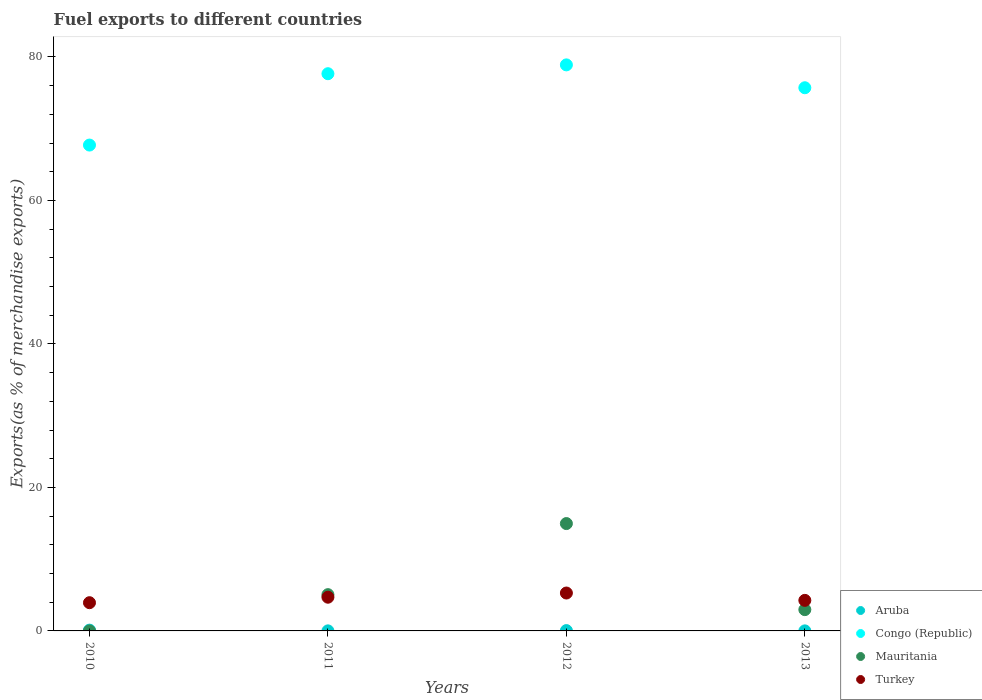How many different coloured dotlines are there?
Your answer should be very brief. 4. Is the number of dotlines equal to the number of legend labels?
Ensure brevity in your answer.  Yes. What is the percentage of exports to different countries in Turkey in 2010?
Give a very brief answer. 3.93. Across all years, what is the maximum percentage of exports to different countries in Congo (Republic)?
Offer a very short reply. 78.9. Across all years, what is the minimum percentage of exports to different countries in Congo (Republic)?
Keep it short and to the point. 67.72. In which year was the percentage of exports to different countries in Turkey maximum?
Your response must be concise. 2012. What is the total percentage of exports to different countries in Congo (Republic) in the graph?
Offer a terse response. 299.99. What is the difference between the percentage of exports to different countries in Turkey in 2010 and that in 2012?
Your answer should be very brief. -1.35. What is the difference between the percentage of exports to different countries in Mauritania in 2011 and the percentage of exports to different countries in Congo (Republic) in 2013?
Provide a succinct answer. -70.65. What is the average percentage of exports to different countries in Congo (Republic) per year?
Your answer should be very brief. 75. In the year 2012, what is the difference between the percentage of exports to different countries in Mauritania and percentage of exports to different countries in Congo (Republic)?
Your answer should be very brief. -63.93. In how many years, is the percentage of exports to different countries in Congo (Republic) greater than 24 %?
Provide a succinct answer. 4. What is the ratio of the percentage of exports to different countries in Congo (Republic) in 2011 to that in 2013?
Provide a short and direct response. 1.03. What is the difference between the highest and the second highest percentage of exports to different countries in Aruba?
Offer a very short reply. 0.06. What is the difference between the highest and the lowest percentage of exports to different countries in Mauritania?
Make the answer very short. 14.96. In how many years, is the percentage of exports to different countries in Aruba greater than the average percentage of exports to different countries in Aruba taken over all years?
Your answer should be compact. 2. Is it the case that in every year, the sum of the percentage of exports to different countries in Mauritania and percentage of exports to different countries in Aruba  is greater than the sum of percentage of exports to different countries in Congo (Republic) and percentage of exports to different countries in Turkey?
Keep it short and to the point. No. Is it the case that in every year, the sum of the percentage of exports to different countries in Turkey and percentage of exports to different countries in Congo (Republic)  is greater than the percentage of exports to different countries in Aruba?
Keep it short and to the point. Yes. Does the percentage of exports to different countries in Mauritania monotonically increase over the years?
Offer a terse response. No. Is the percentage of exports to different countries in Congo (Republic) strictly less than the percentage of exports to different countries in Mauritania over the years?
Keep it short and to the point. No. How many dotlines are there?
Make the answer very short. 4. How many years are there in the graph?
Your response must be concise. 4. Does the graph contain any zero values?
Provide a short and direct response. No. Where does the legend appear in the graph?
Give a very brief answer. Bottom right. How are the legend labels stacked?
Your answer should be compact. Vertical. What is the title of the graph?
Provide a short and direct response. Fuel exports to different countries. Does "Cabo Verde" appear as one of the legend labels in the graph?
Provide a succinct answer. No. What is the label or title of the X-axis?
Provide a short and direct response. Years. What is the label or title of the Y-axis?
Your answer should be very brief. Exports(as % of merchandise exports). What is the Exports(as % of merchandise exports) of Aruba in 2010?
Ensure brevity in your answer.  0.11. What is the Exports(as % of merchandise exports) in Congo (Republic) in 2010?
Give a very brief answer. 67.72. What is the Exports(as % of merchandise exports) of Mauritania in 2010?
Provide a succinct answer. 0. What is the Exports(as % of merchandise exports) of Turkey in 2010?
Your response must be concise. 3.93. What is the Exports(as % of merchandise exports) of Aruba in 2011?
Give a very brief answer. 0.01. What is the Exports(as % of merchandise exports) in Congo (Republic) in 2011?
Offer a very short reply. 77.67. What is the Exports(as % of merchandise exports) in Mauritania in 2011?
Offer a terse response. 5.06. What is the Exports(as % of merchandise exports) of Turkey in 2011?
Make the answer very short. 4.7. What is the Exports(as % of merchandise exports) in Aruba in 2012?
Your answer should be compact. 0.05. What is the Exports(as % of merchandise exports) in Congo (Republic) in 2012?
Offer a very short reply. 78.9. What is the Exports(as % of merchandise exports) of Mauritania in 2012?
Your answer should be compact. 14.96. What is the Exports(as % of merchandise exports) of Turkey in 2012?
Keep it short and to the point. 5.28. What is the Exports(as % of merchandise exports) of Aruba in 2013?
Your response must be concise. 0.01. What is the Exports(as % of merchandise exports) of Congo (Republic) in 2013?
Offer a terse response. 75.71. What is the Exports(as % of merchandise exports) of Mauritania in 2013?
Provide a succinct answer. 2.97. What is the Exports(as % of merchandise exports) of Turkey in 2013?
Provide a succinct answer. 4.26. Across all years, what is the maximum Exports(as % of merchandise exports) of Aruba?
Your answer should be very brief. 0.11. Across all years, what is the maximum Exports(as % of merchandise exports) of Congo (Republic)?
Your answer should be compact. 78.9. Across all years, what is the maximum Exports(as % of merchandise exports) of Mauritania?
Your response must be concise. 14.96. Across all years, what is the maximum Exports(as % of merchandise exports) in Turkey?
Your answer should be very brief. 5.28. Across all years, what is the minimum Exports(as % of merchandise exports) of Aruba?
Keep it short and to the point. 0.01. Across all years, what is the minimum Exports(as % of merchandise exports) of Congo (Republic)?
Offer a very short reply. 67.72. Across all years, what is the minimum Exports(as % of merchandise exports) in Mauritania?
Keep it short and to the point. 0. Across all years, what is the minimum Exports(as % of merchandise exports) in Turkey?
Your response must be concise. 3.93. What is the total Exports(as % of merchandise exports) in Aruba in the graph?
Your answer should be very brief. 0.17. What is the total Exports(as % of merchandise exports) of Congo (Republic) in the graph?
Offer a terse response. 299.99. What is the total Exports(as % of merchandise exports) in Mauritania in the graph?
Offer a terse response. 22.99. What is the total Exports(as % of merchandise exports) of Turkey in the graph?
Give a very brief answer. 18.17. What is the difference between the Exports(as % of merchandise exports) in Aruba in 2010 and that in 2011?
Keep it short and to the point. 0.1. What is the difference between the Exports(as % of merchandise exports) in Congo (Republic) in 2010 and that in 2011?
Offer a terse response. -9.95. What is the difference between the Exports(as % of merchandise exports) in Mauritania in 2010 and that in 2011?
Give a very brief answer. -5.05. What is the difference between the Exports(as % of merchandise exports) of Turkey in 2010 and that in 2011?
Give a very brief answer. -0.77. What is the difference between the Exports(as % of merchandise exports) of Aruba in 2010 and that in 2012?
Give a very brief answer. 0.06. What is the difference between the Exports(as % of merchandise exports) in Congo (Republic) in 2010 and that in 2012?
Provide a succinct answer. -11.18. What is the difference between the Exports(as % of merchandise exports) of Mauritania in 2010 and that in 2012?
Keep it short and to the point. -14.96. What is the difference between the Exports(as % of merchandise exports) in Turkey in 2010 and that in 2012?
Your response must be concise. -1.35. What is the difference between the Exports(as % of merchandise exports) of Aruba in 2010 and that in 2013?
Provide a short and direct response. 0.1. What is the difference between the Exports(as % of merchandise exports) in Congo (Republic) in 2010 and that in 2013?
Your answer should be very brief. -7.99. What is the difference between the Exports(as % of merchandise exports) of Mauritania in 2010 and that in 2013?
Ensure brevity in your answer.  -2.97. What is the difference between the Exports(as % of merchandise exports) in Turkey in 2010 and that in 2013?
Keep it short and to the point. -0.32. What is the difference between the Exports(as % of merchandise exports) of Aruba in 2011 and that in 2012?
Give a very brief answer. -0.04. What is the difference between the Exports(as % of merchandise exports) in Congo (Republic) in 2011 and that in 2012?
Ensure brevity in your answer.  -1.23. What is the difference between the Exports(as % of merchandise exports) of Mauritania in 2011 and that in 2012?
Your answer should be compact. -9.91. What is the difference between the Exports(as % of merchandise exports) of Turkey in 2011 and that in 2012?
Keep it short and to the point. -0.58. What is the difference between the Exports(as % of merchandise exports) of Aruba in 2011 and that in 2013?
Give a very brief answer. 0. What is the difference between the Exports(as % of merchandise exports) in Congo (Republic) in 2011 and that in 2013?
Your answer should be very brief. 1.96. What is the difference between the Exports(as % of merchandise exports) in Mauritania in 2011 and that in 2013?
Provide a succinct answer. 2.09. What is the difference between the Exports(as % of merchandise exports) in Turkey in 2011 and that in 2013?
Ensure brevity in your answer.  0.44. What is the difference between the Exports(as % of merchandise exports) of Aruba in 2012 and that in 2013?
Give a very brief answer. 0.04. What is the difference between the Exports(as % of merchandise exports) in Congo (Republic) in 2012 and that in 2013?
Provide a short and direct response. 3.19. What is the difference between the Exports(as % of merchandise exports) in Mauritania in 2012 and that in 2013?
Provide a succinct answer. 12. What is the difference between the Exports(as % of merchandise exports) in Turkey in 2012 and that in 2013?
Offer a very short reply. 1.02. What is the difference between the Exports(as % of merchandise exports) of Aruba in 2010 and the Exports(as % of merchandise exports) of Congo (Republic) in 2011?
Offer a very short reply. -77.56. What is the difference between the Exports(as % of merchandise exports) of Aruba in 2010 and the Exports(as % of merchandise exports) of Mauritania in 2011?
Provide a short and direct response. -4.95. What is the difference between the Exports(as % of merchandise exports) of Aruba in 2010 and the Exports(as % of merchandise exports) of Turkey in 2011?
Ensure brevity in your answer.  -4.59. What is the difference between the Exports(as % of merchandise exports) of Congo (Republic) in 2010 and the Exports(as % of merchandise exports) of Mauritania in 2011?
Provide a succinct answer. 62.67. What is the difference between the Exports(as % of merchandise exports) of Congo (Republic) in 2010 and the Exports(as % of merchandise exports) of Turkey in 2011?
Offer a terse response. 63.02. What is the difference between the Exports(as % of merchandise exports) in Mauritania in 2010 and the Exports(as % of merchandise exports) in Turkey in 2011?
Keep it short and to the point. -4.7. What is the difference between the Exports(as % of merchandise exports) in Aruba in 2010 and the Exports(as % of merchandise exports) in Congo (Republic) in 2012?
Offer a very short reply. -78.79. What is the difference between the Exports(as % of merchandise exports) in Aruba in 2010 and the Exports(as % of merchandise exports) in Mauritania in 2012?
Your response must be concise. -14.86. What is the difference between the Exports(as % of merchandise exports) of Aruba in 2010 and the Exports(as % of merchandise exports) of Turkey in 2012?
Make the answer very short. -5.18. What is the difference between the Exports(as % of merchandise exports) in Congo (Republic) in 2010 and the Exports(as % of merchandise exports) in Mauritania in 2012?
Give a very brief answer. 52.76. What is the difference between the Exports(as % of merchandise exports) of Congo (Republic) in 2010 and the Exports(as % of merchandise exports) of Turkey in 2012?
Provide a succinct answer. 62.44. What is the difference between the Exports(as % of merchandise exports) in Mauritania in 2010 and the Exports(as % of merchandise exports) in Turkey in 2012?
Provide a succinct answer. -5.28. What is the difference between the Exports(as % of merchandise exports) in Aruba in 2010 and the Exports(as % of merchandise exports) in Congo (Republic) in 2013?
Make the answer very short. -75.6. What is the difference between the Exports(as % of merchandise exports) of Aruba in 2010 and the Exports(as % of merchandise exports) of Mauritania in 2013?
Provide a succinct answer. -2.86. What is the difference between the Exports(as % of merchandise exports) of Aruba in 2010 and the Exports(as % of merchandise exports) of Turkey in 2013?
Your answer should be compact. -4.15. What is the difference between the Exports(as % of merchandise exports) in Congo (Republic) in 2010 and the Exports(as % of merchandise exports) in Mauritania in 2013?
Your answer should be compact. 64.75. What is the difference between the Exports(as % of merchandise exports) of Congo (Republic) in 2010 and the Exports(as % of merchandise exports) of Turkey in 2013?
Make the answer very short. 63.46. What is the difference between the Exports(as % of merchandise exports) of Mauritania in 2010 and the Exports(as % of merchandise exports) of Turkey in 2013?
Your response must be concise. -4.26. What is the difference between the Exports(as % of merchandise exports) in Aruba in 2011 and the Exports(as % of merchandise exports) in Congo (Republic) in 2012?
Offer a terse response. -78.89. What is the difference between the Exports(as % of merchandise exports) of Aruba in 2011 and the Exports(as % of merchandise exports) of Mauritania in 2012?
Make the answer very short. -14.96. What is the difference between the Exports(as % of merchandise exports) in Aruba in 2011 and the Exports(as % of merchandise exports) in Turkey in 2012?
Provide a short and direct response. -5.27. What is the difference between the Exports(as % of merchandise exports) in Congo (Republic) in 2011 and the Exports(as % of merchandise exports) in Mauritania in 2012?
Give a very brief answer. 62.7. What is the difference between the Exports(as % of merchandise exports) in Congo (Republic) in 2011 and the Exports(as % of merchandise exports) in Turkey in 2012?
Your answer should be very brief. 72.38. What is the difference between the Exports(as % of merchandise exports) of Mauritania in 2011 and the Exports(as % of merchandise exports) of Turkey in 2012?
Ensure brevity in your answer.  -0.23. What is the difference between the Exports(as % of merchandise exports) of Aruba in 2011 and the Exports(as % of merchandise exports) of Congo (Republic) in 2013?
Keep it short and to the point. -75.7. What is the difference between the Exports(as % of merchandise exports) in Aruba in 2011 and the Exports(as % of merchandise exports) in Mauritania in 2013?
Offer a terse response. -2.96. What is the difference between the Exports(as % of merchandise exports) in Aruba in 2011 and the Exports(as % of merchandise exports) in Turkey in 2013?
Keep it short and to the point. -4.25. What is the difference between the Exports(as % of merchandise exports) of Congo (Republic) in 2011 and the Exports(as % of merchandise exports) of Mauritania in 2013?
Offer a terse response. 74.7. What is the difference between the Exports(as % of merchandise exports) of Congo (Republic) in 2011 and the Exports(as % of merchandise exports) of Turkey in 2013?
Ensure brevity in your answer.  73.41. What is the difference between the Exports(as % of merchandise exports) of Mauritania in 2011 and the Exports(as % of merchandise exports) of Turkey in 2013?
Provide a succinct answer. 0.8. What is the difference between the Exports(as % of merchandise exports) in Aruba in 2012 and the Exports(as % of merchandise exports) in Congo (Republic) in 2013?
Ensure brevity in your answer.  -75.66. What is the difference between the Exports(as % of merchandise exports) in Aruba in 2012 and the Exports(as % of merchandise exports) in Mauritania in 2013?
Your answer should be very brief. -2.92. What is the difference between the Exports(as % of merchandise exports) of Aruba in 2012 and the Exports(as % of merchandise exports) of Turkey in 2013?
Provide a succinct answer. -4.21. What is the difference between the Exports(as % of merchandise exports) in Congo (Republic) in 2012 and the Exports(as % of merchandise exports) in Mauritania in 2013?
Ensure brevity in your answer.  75.93. What is the difference between the Exports(as % of merchandise exports) in Congo (Republic) in 2012 and the Exports(as % of merchandise exports) in Turkey in 2013?
Keep it short and to the point. 74.64. What is the difference between the Exports(as % of merchandise exports) of Mauritania in 2012 and the Exports(as % of merchandise exports) of Turkey in 2013?
Keep it short and to the point. 10.71. What is the average Exports(as % of merchandise exports) of Aruba per year?
Ensure brevity in your answer.  0.04. What is the average Exports(as % of merchandise exports) of Congo (Republic) per year?
Your answer should be very brief. 75. What is the average Exports(as % of merchandise exports) of Mauritania per year?
Provide a short and direct response. 5.75. What is the average Exports(as % of merchandise exports) of Turkey per year?
Your answer should be compact. 4.54. In the year 2010, what is the difference between the Exports(as % of merchandise exports) of Aruba and Exports(as % of merchandise exports) of Congo (Republic)?
Keep it short and to the point. -67.61. In the year 2010, what is the difference between the Exports(as % of merchandise exports) of Aruba and Exports(as % of merchandise exports) of Mauritania?
Give a very brief answer. 0.11. In the year 2010, what is the difference between the Exports(as % of merchandise exports) of Aruba and Exports(as % of merchandise exports) of Turkey?
Provide a short and direct response. -3.83. In the year 2010, what is the difference between the Exports(as % of merchandise exports) of Congo (Republic) and Exports(as % of merchandise exports) of Mauritania?
Give a very brief answer. 67.72. In the year 2010, what is the difference between the Exports(as % of merchandise exports) in Congo (Republic) and Exports(as % of merchandise exports) in Turkey?
Keep it short and to the point. 63.79. In the year 2010, what is the difference between the Exports(as % of merchandise exports) of Mauritania and Exports(as % of merchandise exports) of Turkey?
Your answer should be compact. -3.93. In the year 2011, what is the difference between the Exports(as % of merchandise exports) in Aruba and Exports(as % of merchandise exports) in Congo (Republic)?
Give a very brief answer. -77.66. In the year 2011, what is the difference between the Exports(as % of merchandise exports) in Aruba and Exports(as % of merchandise exports) in Mauritania?
Offer a terse response. -5.05. In the year 2011, what is the difference between the Exports(as % of merchandise exports) in Aruba and Exports(as % of merchandise exports) in Turkey?
Ensure brevity in your answer.  -4.69. In the year 2011, what is the difference between the Exports(as % of merchandise exports) of Congo (Republic) and Exports(as % of merchandise exports) of Mauritania?
Provide a succinct answer. 72.61. In the year 2011, what is the difference between the Exports(as % of merchandise exports) in Congo (Republic) and Exports(as % of merchandise exports) in Turkey?
Make the answer very short. 72.97. In the year 2011, what is the difference between the Exports(as % of merchandise exports) of Mauritania and Exports(as % of merchandise exports) of Turkey?
Keep it short and to the point. 0.36. In the year 2012, what is the difference between the Exports(as % of merchandise exports) in Aruba and Exports(as % of merchandise exports) in Congo (Republic)?
Give a very brief answer. -78.85. In the year 2012, what is the difference between the Exports(as % of merchandise exports) of Aruba and Exports(as % of merchandise exports) of Mauritania?
Ensure brevity in your answer.  -14.92. In the year 2012, what is the difference between the Exports(as % of merchandise exports) in Aruba and Exports(as % of merchandise exports) in Turkey?
Ensure brevity in your answer.  -5.24. In the year 2012, what is the difference between the Exports(as % of merchandise exports) in Congo (Republic) and Exports(as % of merchandise exports) in Mauritania?
Offer a very short reply. 63.93. In the year 2012, what is the difference between the Exports(as % of merchandise exports) in Congo (Republic) and Exports(as % of merchandise exports) in Turkey?
Your answer should be very brief. 73.62. In the year 2012, what is the difference between the Exports(as % of merchandise exports) in Mauritania and Exports(as % of merchandise exports) in Turkey?
Your answer should be compact. 9.68. In the year 2013, what is the difference between the Exports(as % of merchandise exports) of Aruba and Exports(as % of merchandise exports) of Congo (Republic)?
Provide a short and direct response. -75.7. In the year 2013, what is the difference between the Exports(as % of merchandise exports) in Aruba and Exports(as % of merchandise exports) in Mauritania?
Your answer should be very brief. -2.96. In the year 2013, what is the difference between the Exports(as % of merchandise exports) of Aruba and Exports(as % of merchandise exports) of Turkey?
Provide a short and direct response. -4.25. In the year 2013, what is the difference between the Exports(as % of merchandise exports) of Congo (Republic) and Exports(as % of merchandise exports) of Mauritania?
Ensure brevity in your answer.  72.74. In the year 2013, what is the difference between the Exports(as % of merchandise exports) of Congo (Republic) and Exports(as % of merchandise exports) of Turkey?
Keep it short and to the point. 71.45. In the year 2013, what is the difference between the Exports(as % of merchandise exports) in Mauritania and Exports(as % of merchandise exports) in Turkey?
Your answer should be compact. -1.29. What is the ratio of the Exports(as % of merchandise exports) of Aruba in 2010 to that in 2011?
Ensure brevity in your answer.  12.74. What is the ratio of the Exports(as % of merchandise exports) of Congo (Republic) in 2010 to that in 2011?
Your answer should be compact. 0.87. What is the ratio of the Exports(as % of merchandise exports) of Mauritania in 2010 to that in 2011?
Your response must be concise. 0. What is the ratio of the Exports(as % of merchandise exports) of Turkey in 2010 to that in 2011?
Provide a succinct answer. 0.84. What is the ratio of the Exports(as % of merchandise exports) of Aruba in 2010 to that in 2012?
Offer a very short reply. 2.34. What is the ratio of the Exports(as % of merchandise exports) of Congo (Republic) in 2010 to that in 2012?
Your response must be concise. 0.86. What is the ratio of the Exports(as % of merchandise exports) in Turkey in 2010 to that in 2012?
Make the answer very short. 0.74. What is the ratio of the Exports(as % of merchandise exports) in Aruba in 2010 to that in 2013?
Give a very brief answer. 15.27. What is the ratio of the Exports(as % of merchandise exports) in Congo (Republic) in 2010 to that in 2013?
Make the answer very short. 0.89. What is the ratio of the Exports(as % of merchandise exports) in Mauritania in 2010 to that in 2013?
Your answer should be compact. 0. What is the ratio of the Exports(as % of merchandise exports) in Turkey in 2010 to that in 2013?
Ensure brevity in your answer.  0.92. What is the ratio of the Exports(as % of merchandise exports) of Aruba in 2011 to that in 2012?
Offer a very short reply. 0.18. What is the ratio of the Exports(as % of merchandise exports) in Congo (Republic) in 2011 to that in 2012?
Your answer should be compact. 0.98. What is the ratio of the Exports(as % of merchandise exports) in Mauritania in 2011 to that in 2012?
Provide a short and direct response. 0.34. What is the ratio of the Exports(as % of merchandise exports) in Turkey in 2011 to that in 2012?
Your answer should be compact. 0.89. What is the ratio of the Exports(as % of merchandise exports) of Aruba in 2011 to that in 2013?
Offer a terse response. 1.2. What is the ratio of the Exports(as % of merchandise exports) of Congo (Republic) in 2011 to that in 2013?
Offer a terse response. 1.03. What is the ratio of the Exports(as % of merchandise exports) in Mauritania in 2011 to that in 2013?
Offer a very short reply. 1.7. What is the ratio of the Exports(as % of merchandise exports) in Turkey in 2011 to that in 2013?
Offer a terse response. 1.1. What is the ratio of the Exports(as % of merchandise exports) of Aruba in 2012 to that in 2013?
Your response must be concise. 6.52. What is the ratio of the Exports(as % of merchandise exports) in Congo (Republic) in 2012 to that in 2013?
Keep it short and to the point. 1.04. What is the ratio of the Exports(as % of merchandise exports) in Mauritania in 2012 to that in 2013?
Give a very brief answer. 5.04. What is the ratio of the Exports(as % of merchandise exports) in Turkey in 2012 to that in 2013?
Offer a terse response. 1.24. What is the difference between the highest and the second highest Exports(as % of merchandise exports) in Aruba?
Your answer should be very brief. 0.06. What is the difference between the highest and the second highest Exports(as % of merchandise exports) in Congo (Republic)?
Your answer should be very brief. 1.23. What is the difference between the highest and the second highest Exports(as % of merchandise exports) of Mauritania?
Your response must be concise. 9.91. What is the difference between the highest and the second highest Exports(as % of merchandise exports) of Turkey?
Offer a very short reply. 0.58. What is the difference between the highest and the lowest Exports(as % of merchandise exports) of Aruba?
Offer a very short reply. 0.1. What is the difference between the highest and the lowest Exports(as % of merchandise exports) of Congo (Republic)?
Your answer should be compact. 11.18. What is the difference between the highest and the lowest Exports(as % of merchandise exports) of Mauritania?
Your answer should be very brief. 14.96. What is the difference between the highest and the lowest Exports(as % of merchandise exports) in Turkey?
Your answer should be compact. 1.35. 